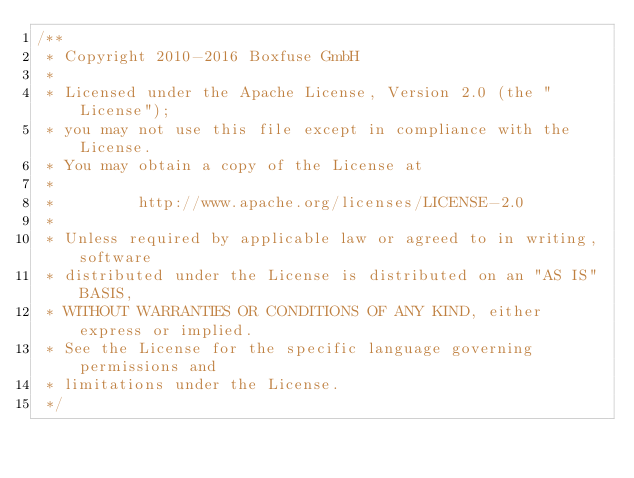<code> <loc_0><loc_0><loc_500><loc_500><_Java_>/**
 * Copyright 2010-2016 Boxfuse GmbH
 *
 * Licensed under the Apache License, Version 2.0 (the "License");
 * you may not use this file except in compliance with the License.
 * You may obtain a copy of the License at
 *
 *         http://www.apache.org/licenses/LICENSE-2.0
 *
 * Unless required by applicable law or agreed to in writing, software
 * distributed under the License is distributed on an "AS IS" BASIS,
 * WITHOUT WARRANTIES OR CONDITIONS OF ANY KIND, either express or implied.
 * See the License for the specific language governing permissions and
 * limitations under the License.
 */</code> 